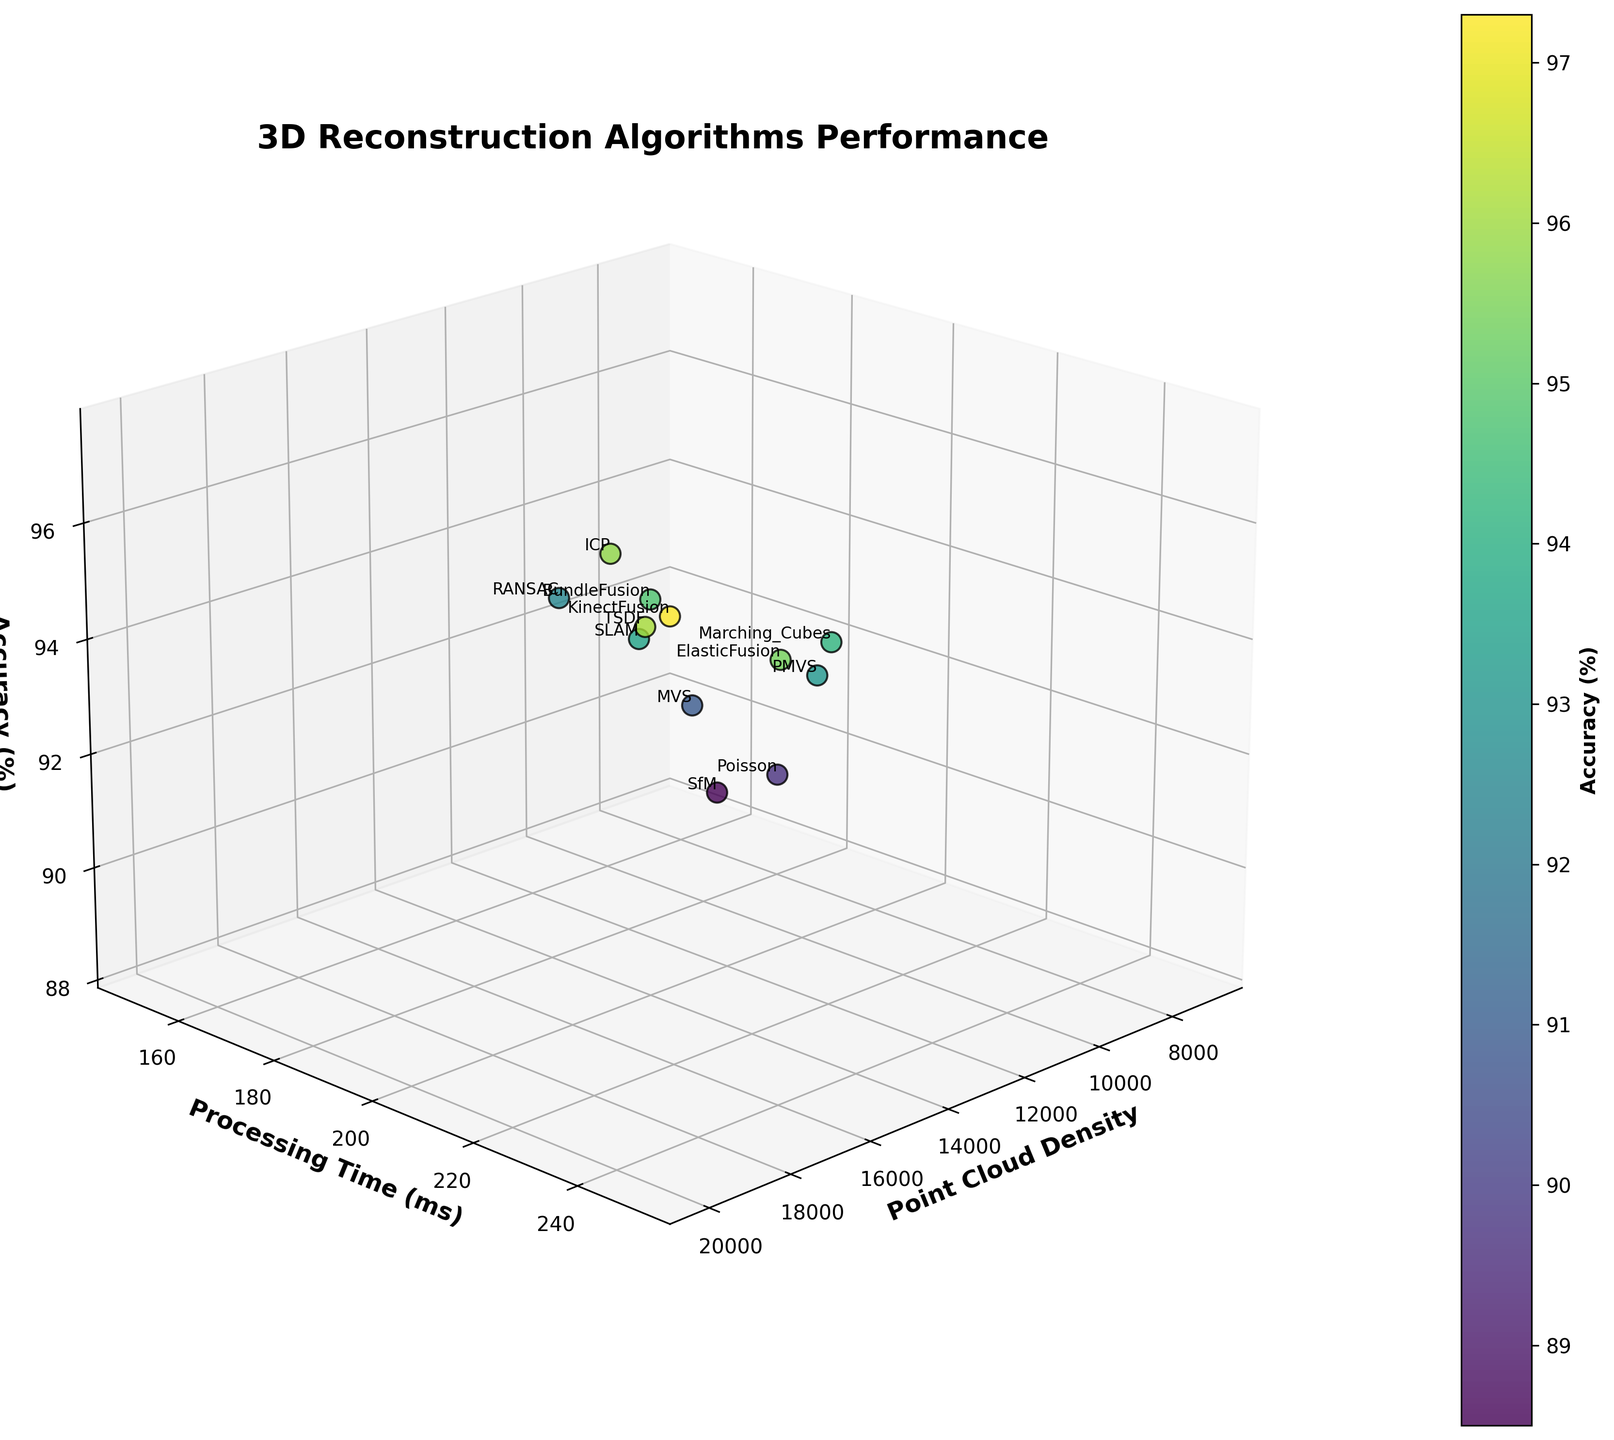How many algorithms are evaluated in the figure? Count the number of data points present in the scatterplot, each corresponding to a different algorithm.
Answer: 12 What is the title of the figure? Read the main title at the top of the figure.
Answer: 3D Reconstruction Algorithms Performance Which algorithm has the highest processing time? Look for the data point with the highest value on the Processing Time axis, then identify the associated algorithm by its label.
Answer: KinectFusion Which two algorithms have the closest accuracy percentages and what are their values? Compare the accuracy percentages visually and find the two points that are closest to each other along the Accuracy axis, then note their values.
Answer: ELASTICFUSION and ICP, both with approximately 95.4% and 95.8% respectively What is the average point cloud density for the algorithms with accuracies above 94%? Identify the data points with accuracies above 94%, sum their point cloud densities, and divide by the number of such data points.
Answer: 15500 Which algorithm provides the highest accuracy and what is its corresponding point cloud density? Find the highest point on the Accuracy axis and identify the corresponding algorithm and Point Cloud Density value.
Answer: KinectFusion, 20000 Does Poisson algorithm have a higher accuracy than Marching Cubes? Locate the positions of Poisson and Marching Cubes on the Accuracy axis and compare their values.
Answer: No What is the range of processing times for the algorithms? Identify the minimum and maximum values on the Processing Time axis and subtract to find the range.
Answer: 100 ms How does the algorithm with the lowest point cloud density perform in terms of accuracy? Identify the algorithm with the lowest point on the Point Cloud Density axis and check its value on the Accuracy axis.
Answer: Poisson, 89.7% Which algorithm has the slowest processing time but still achieves an accuracy over 95%? Locate the data points with accuracies over 95% and find the one with the highest Processing Time value.
Answer: KinectFusion 